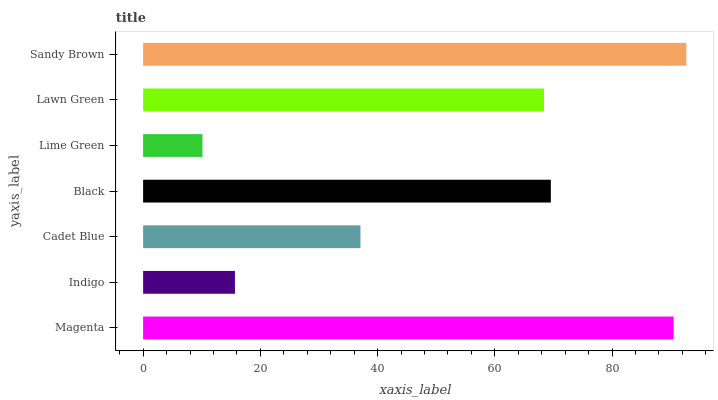Is Lime Green the minimum?
Answer yes or no. Yes. Is Sandy Brown the maximum?
Answer yes or no. Yes. Is Indigo the minimum?
Answer yes or no. No. Is Indigo the maximum?
Answer yes or no. No. Is Magenta greater than Indigo?
Answer yes or no. Yes. Is Indigo less than Magenta?
Answer yes or no. Yes. Is Indigo greater than Magenta?
Answer yes or no. No. Is Magenta less than Indigo?
Answer yes or no. No. Is Lawn Green the high median?
Answer yes or no. Yes. Is Lawn Green the low median?
Answer yes or no. Yes. Is Indigo the high median?
Answer yes or no. No. Is Indigo the low median?
Answer yes or no. No. 